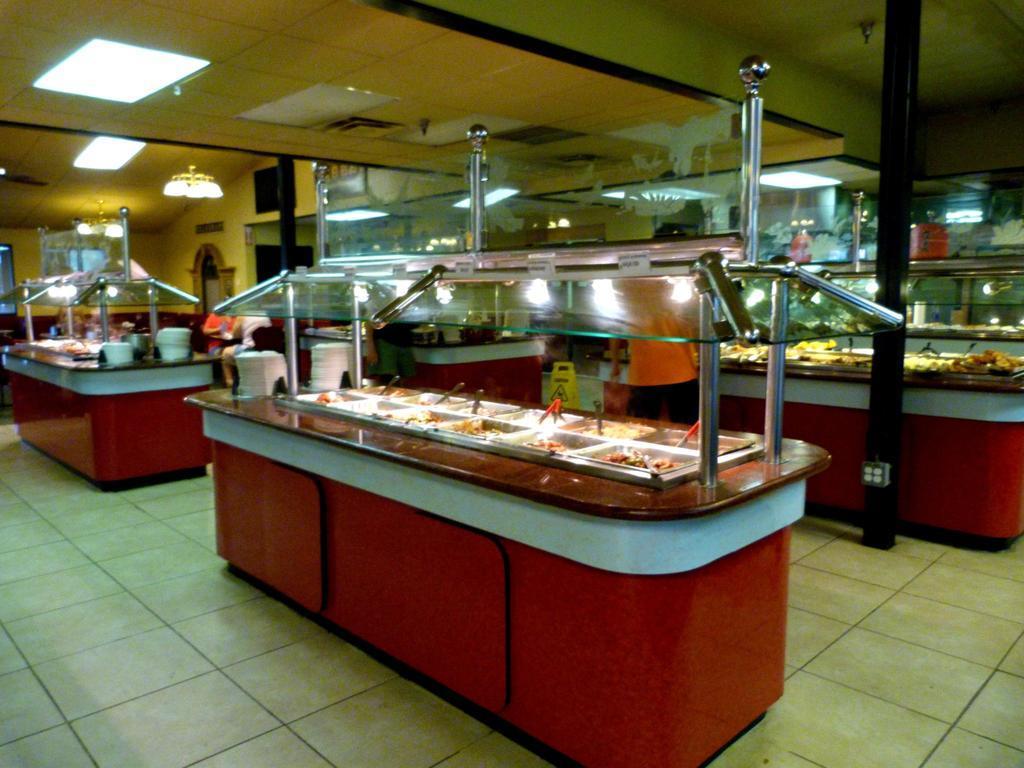How would you summarize this image in a sentence or two? In this image I can see there are four tables , there are some containers kept on the table , on the container I can see a food and a person visible in front of a table ,at the top there is a roof, on the roof I can see lights and a pole visible on the right side 